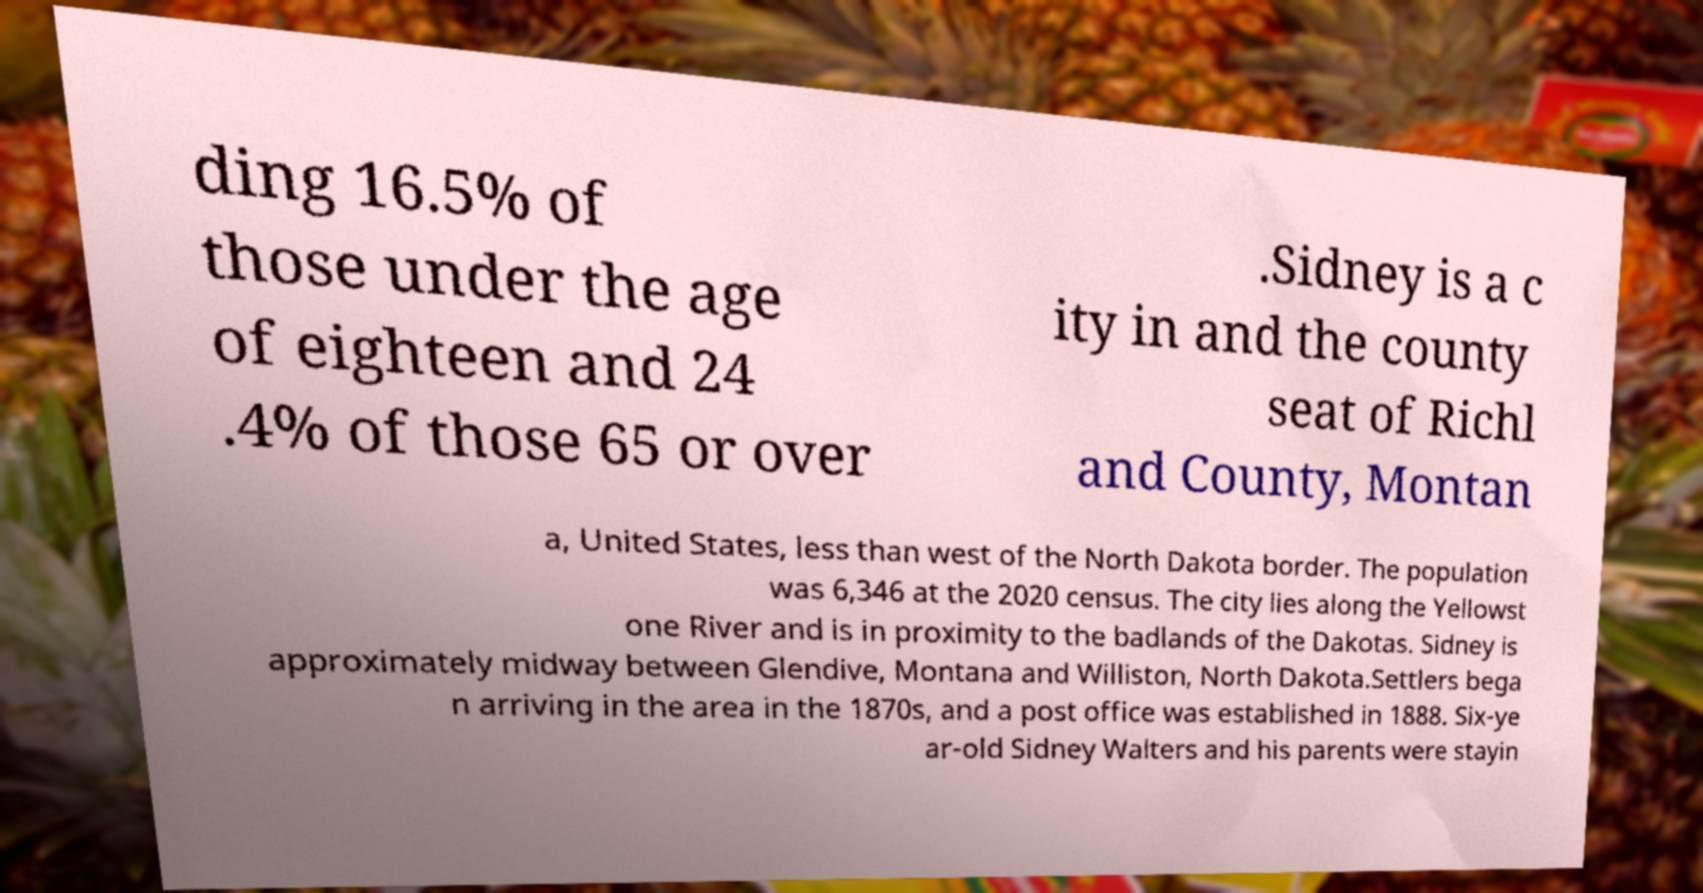Can you read and provide the text displayed in the image?This photo seems to have some interesting text. Can you extract and type it out for me? ding 16.5% of those under the age of eighteen and 24 .4% of those 65 or over .Sidney is a c ity in and the county seat of Richl and County, Montan a, United States, less than west of the North Dakota border. The population was 6,346 at the 2020 census. The city lies along the Yellowst one River and is in proximity to the badlands of the Dakotas. Sidney is approximately midway between Glendive, Montana and Williston, North Dakota.Settlers bega n arriving in the area in the 1870s, and a post office was established in 1888. Six-ye ar-old Sidney Walters and his parents were stayin 